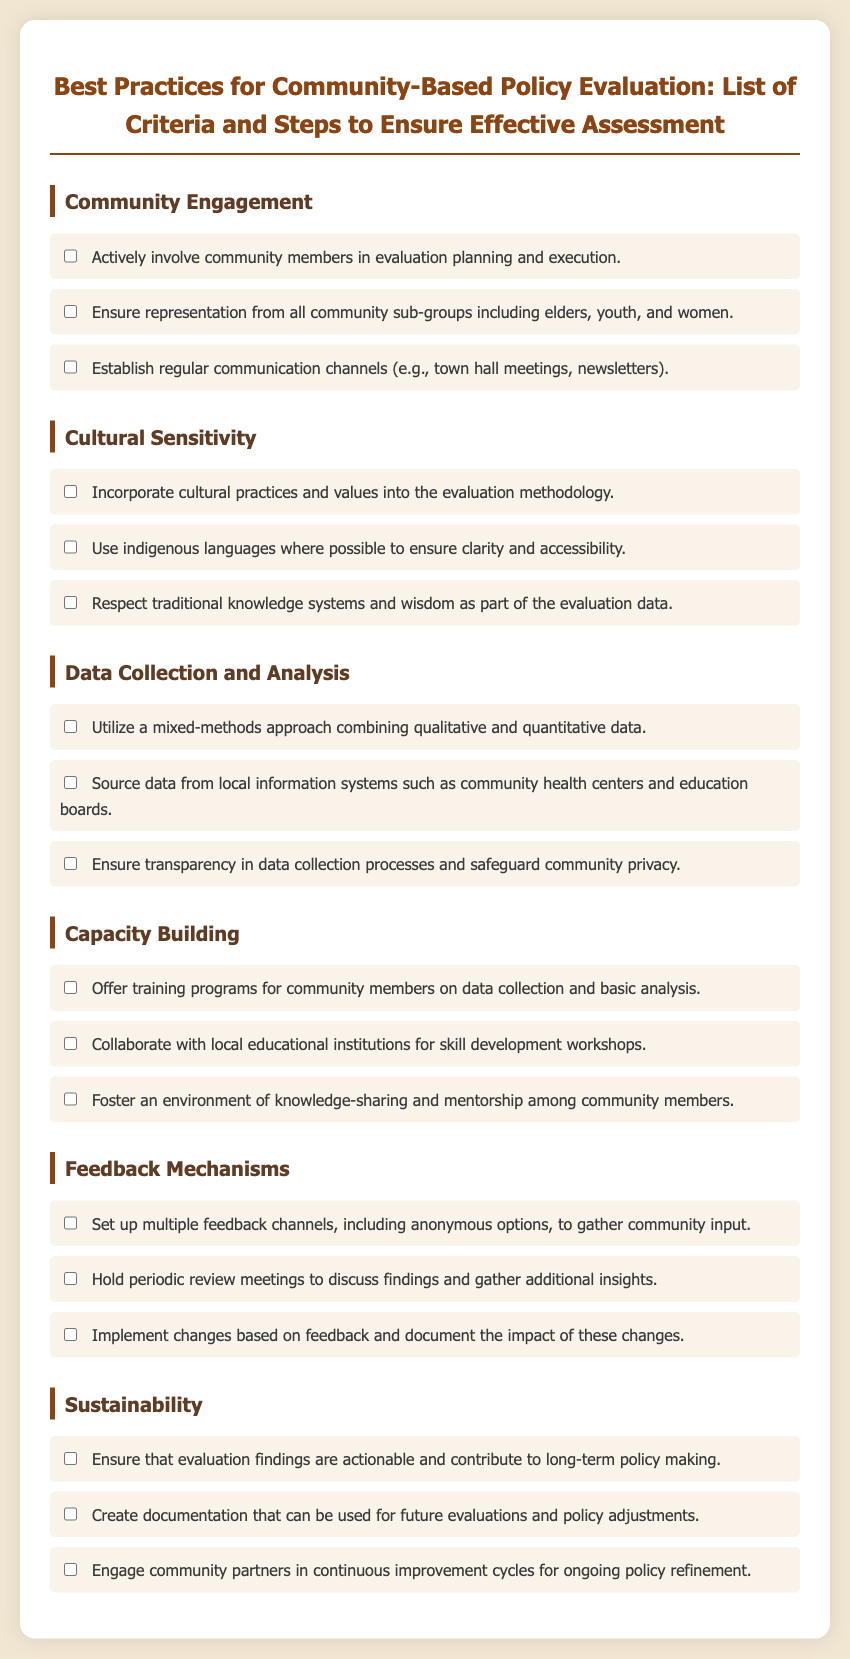what is the first criterion listed for community engagement? The first criterion for community engagement is to actively involve community members in evaluation planning and execution.
Answer: actively involve community members in evaluation planning and execution how many steps are listed under cultural sensitivity? There are three steps listed under cultural sensitivity in the document.
Answer: 3 what type of approach should be utilized for data collection? The document states to utilize a mixed-methods approach combining qualitative and quantitative data.
Answer: mixed-methods approach who should be involved in training programs for capacity building? The training programs for capacity building should involve community members.
Answer: community members what mechanism should be set up to gather community input? The document suggests setting up multiple feedback channels, including anonymous options, to gather community input.
Answer: multiple feedback channels how many criteria are outlined under sustainability? There are three criteria outlined under sustainability in the document.
Answer: 3 which group is specifically mentioned under community engagement for representation? Elders are specifically mentioned for representation under community engagement.
Answer: elders what is emphasized for the impact of changes based on feedback? The document states to document the impact of these changes.
Answer: document the impact of these changes 